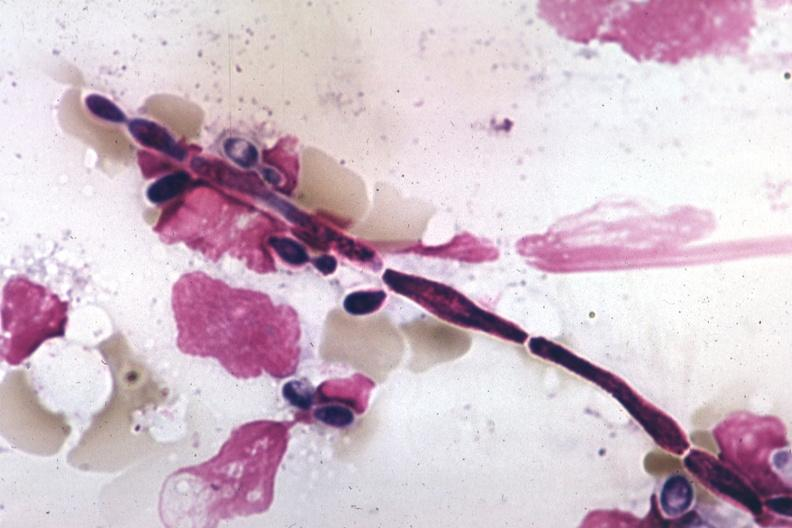s anencephaly present?
Answer the question using a single word or phrase. No 